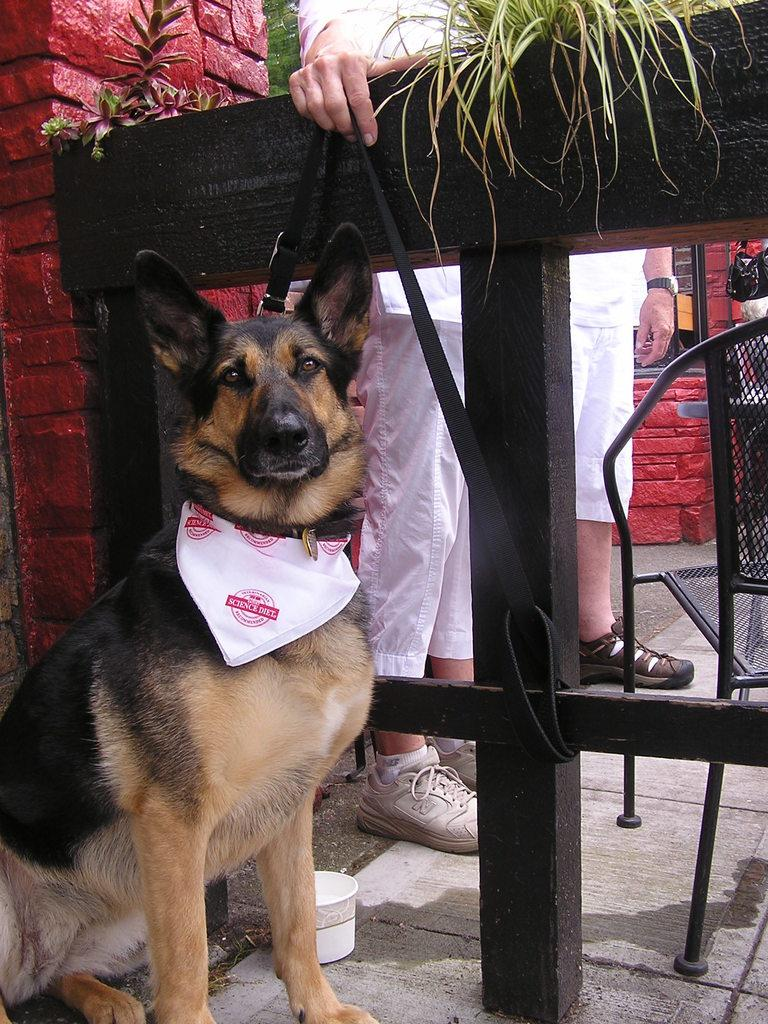What type of animal is on the left side of the image? There is a dog on the left side of the image. Who or what else is present in the image? There are people in the image. What piece of furniture can be seen on the right side of the image? There is a chair on the right side of the image. What type of wine is being served at the dog's birthday party in the image? There is no wine or birthday party present in the image; it features a dog and people. Can you tell me how many dinosaurs are visible in the image? There are no dinosaurs present in the image. 